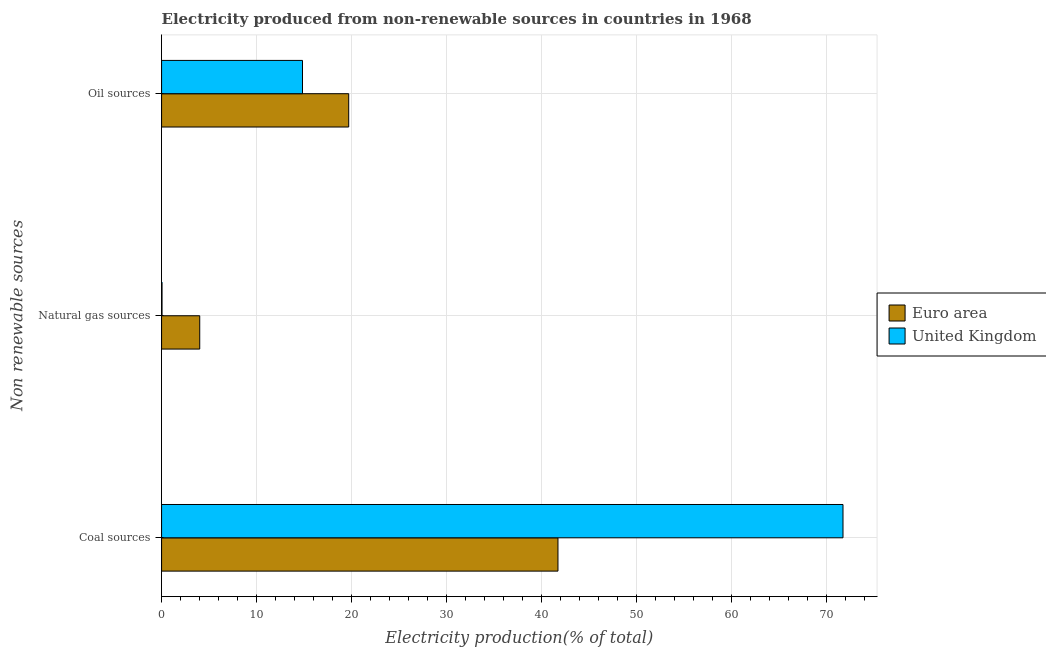How many bars are there on the 2nd tick from the bottom?
Your answer should be compact. 2. What is the label of the 1st group of bars from the top?
Give a very brief answer. Oil sources. What is the percentage of electricity produced by oil sources in United Kingdom?
Provide a short and direct response. 14.84. Across all countries, what is the maximum percentage of electricity produced by natural gas?
Give a very brief answer. 4.02. Across all countries, what is the minimum percentage of electricity produced by natural gas?
Your answer should be compact. 0.05. In which country was the percentage of electricity produced by coal maximum?
Your answer should be compact. United Kingdom. What is the total percentage of electricity produced by oil sources in the graph?
Make the answer very short. 34.54. What is the difference between the percentage of electricity produced by natural gas in United Kingdom and that in Euro area?
Give a very brief answer. -3.97. What is the difference between the percentage of electricity produced by oil sources in Euro area and the percentage of electricity produced by natural gas in United Kingdom?
Your answer should be compact. 19.66. What is the average percentage of electricity produced by oil sources per country?
Keep it short and to the point. 17.27. What is the difference between the percentage of electricity produced by coal and percentage of electricity produced by oil sources in Euro area?
Your answer should be very brief. 22.03. In how many countries, is the percentage of electricity produced by coal greater than 46 %?
Keep it short and to the point. 1. What is the ratio of the percentage of electricity produced by coal in Euro area to that in United Kingdom?
Your answer should be compact. 0.58. Is the difference between the percentage of electricity produced by oil sources in Euro area and United Kingdom greater than the difference between the percentage of electricity produced by natural gas in Euro area and United Kingdom?
Offer a terse response. Yes. What is the difference between the highest and the second highest percentage of electricity produced by natural gas?
Your answer should be very brief. 3.97. What is the difference between the highest and the lowest percentage of electricity produced by natural gas?
Provide a succinct answer. 3.97. What does the 2nd bar from the bottom in Natural gas sources represents?
Ensure brevity in your answer.  United Kingdom. Are all the bars in the graph horizontal?
Keep it short and to the point. Yes. How many countries are there in the graph?
Give a very brief answer. 2. What is the difference between two consecutive major ticks on the X-axis?
Offer a terse response. 10. Are the values on the major ticks of X-axis written in scientific E-notation?
Give a very brief answer. No. Does the graph contain grids?
Make the answer very short. Yes. What is the title of the graph?
Offer a terse response. Electricity produced from non-renewable sources in countries in 1968. Does "St. Vincent and the Grenadines" appear as one of the legend labels in the graph?
Ensure brevity in your answer.  No. What is the label or title of the Y-axis?
Make the answer very short. Non renewable sources. What is the Electricity production(% of total) in Euro area in Coal sources?
Make the answer very short. 41.74. What is the Electricity production(% of total) of United Kingdom in Coal sources?
Your response must be concise. 71.75. What is the Electricity production(% of total) of Euro area in Natural gas sources?
Keep it short and to the point. 4.02. What is the Electricity production(% of total) of United Kingdom in Natural gas sources?
Offer a very short reply. 0.05. What is the Electricity production(% of total) in Euro area in Oil sources?
Your answer should be very brief. 19.7. What is the Electricity production(% of total) of United Kingdom in Oil sources?
Give a very brief answer. 14.84. Across all Non renewable sources, what is the maximum Electricity production(% of total) in Euro area?
Your answer should be compact. 41.74. Across all Non renewable sources, what is the maximum Electricity production(% of total) in United Kingdom?
Make the answer very short. 71.75. Across all Non renewable sources, what is the minimum Electricity production(% of total) of Euro area?
Provide a short and direct response. 4.02. Across all Non renewable sources, what is the minimum Electricity production(% of total) in United Kingdom?
Your response must be concise. 0.05. What is the total Electricity production(% of total) in Euro area in the graph?
Your response must be concise. 65.46. What is the total Electricity production(% of total) of United Kingdom in the graph?
Your answer should be compact. 86.64. What is the difference between the Electricity production(% of total) in Euro area in Coal sources and that in Natural gas sources?
Your answer should be very brief. 37.72. What is the difference between the Electricity production(% of total) of United Kingdom in Coal sources and that in Natural gas sources?
Make the answer very short. 71.7. What is the difference between the Electricity production(% of total) in Euro area in Coal sources and that in Oil sources?
Make the answer very short. 22.03. What is the difference between the Electricity production(% of total) in United Kingdom in Coal sources and that in Oil sources?
Ensure brevity in your answer.  56.91. What is the difference between the Electricity production(% of total) in Euro area in Natural gas sources and that in Oil sources?
Keep it short and to the point. -15.69. What is the difference between the Electricity production(% of total) in United Kingdom in Natural gas sources and that in Oil sources?
Offer a very short reply. -14.79. What is the difference between the Electricity production(% of total) in Euro area in Coal sources and the Electricity production(% of total) in United Kingdom in Natural gas sources?
Your response must be concise. 41.69. What is the difference between the Electricity production(% of total) in Euro area in Coal sources and the Electricity production(% of total) in United Kingdom in Oil sources?
Ensure brevity in your answer.  26.9. What is the difference between the Electricity production(% of total) of Euro area in Natural gas sources and the Electricity production(% of total) of United Kingdom in Oil sources?
Your response must be concise. -10.82. What is the average Electricity production(% of total) of Euro area per Non renewable sources?
Offer a terse response. 21.82. What is the average Electricity production(% of total) of United Kingdom per Non renewable sources?
Offer a terse response. 28.88. What is the difference between the Electricity production(% of total) in Euro area and Electricity production(% of total) in United Kingdom in Coal sources?
Offer a very short reply. -30.01. What is the difference between the Electricity production(% of total) in Euro area and Electricity production(% of total) in United Kingdom in Natural gas sources?
Your response must be concise. 3.97. What is the difference between the Electricity production(% of total) of Euro area and Electricity production(% of total) of United Kingdom in Oil sources?
Provide a short and direct response. 4.87. What is the ratio of the Electricity production(% of total) in Euro area in Coal sources to that in Natural gas sources?
Offer a very short reply. 10.39. What is the ratio of the Electricity production(% of total) of United Kingdom in Coal sources to that in Natural gas sources?
Your answer should be very brief. 1492.79. What is the ratio of the Electricity production(% of total) of Euro area in Coal sources to that in Oil sources?
Offer a terse response. 2.12. What is the ratio of the Electricity production(% of total) in United Kingdom in Coal sources to that in Oil sources?
Provide a short and direct response. 4.84. What is the ratio of the Electricity production(% of total) of Euro area in Natural gas sources to that in Oil sources?
Your answer should be very brief. 0.2. What is the ratio of the Electricity production(% of total) of United Kingdom in Natural gas sources to that in Oil sources?
Your answer should be compact. 0. What is the difference between the highest and the second highest Electricity production(% of total) of Euro area?
Your answer should be very brief. 22.03. What is the difference between the highest and the second highest Electricity production(% of total) in United Kingdom?
Keep it short and to the point. 56.91. What is the difference between the highest and the lowest Electricity production(% of total) of Euro area?
Your answer should be compact. 37.72. What is the difference between the highest and the lowest Electricity production(% of total) in United Kingdom?
Offer a terse response. 71.7. 